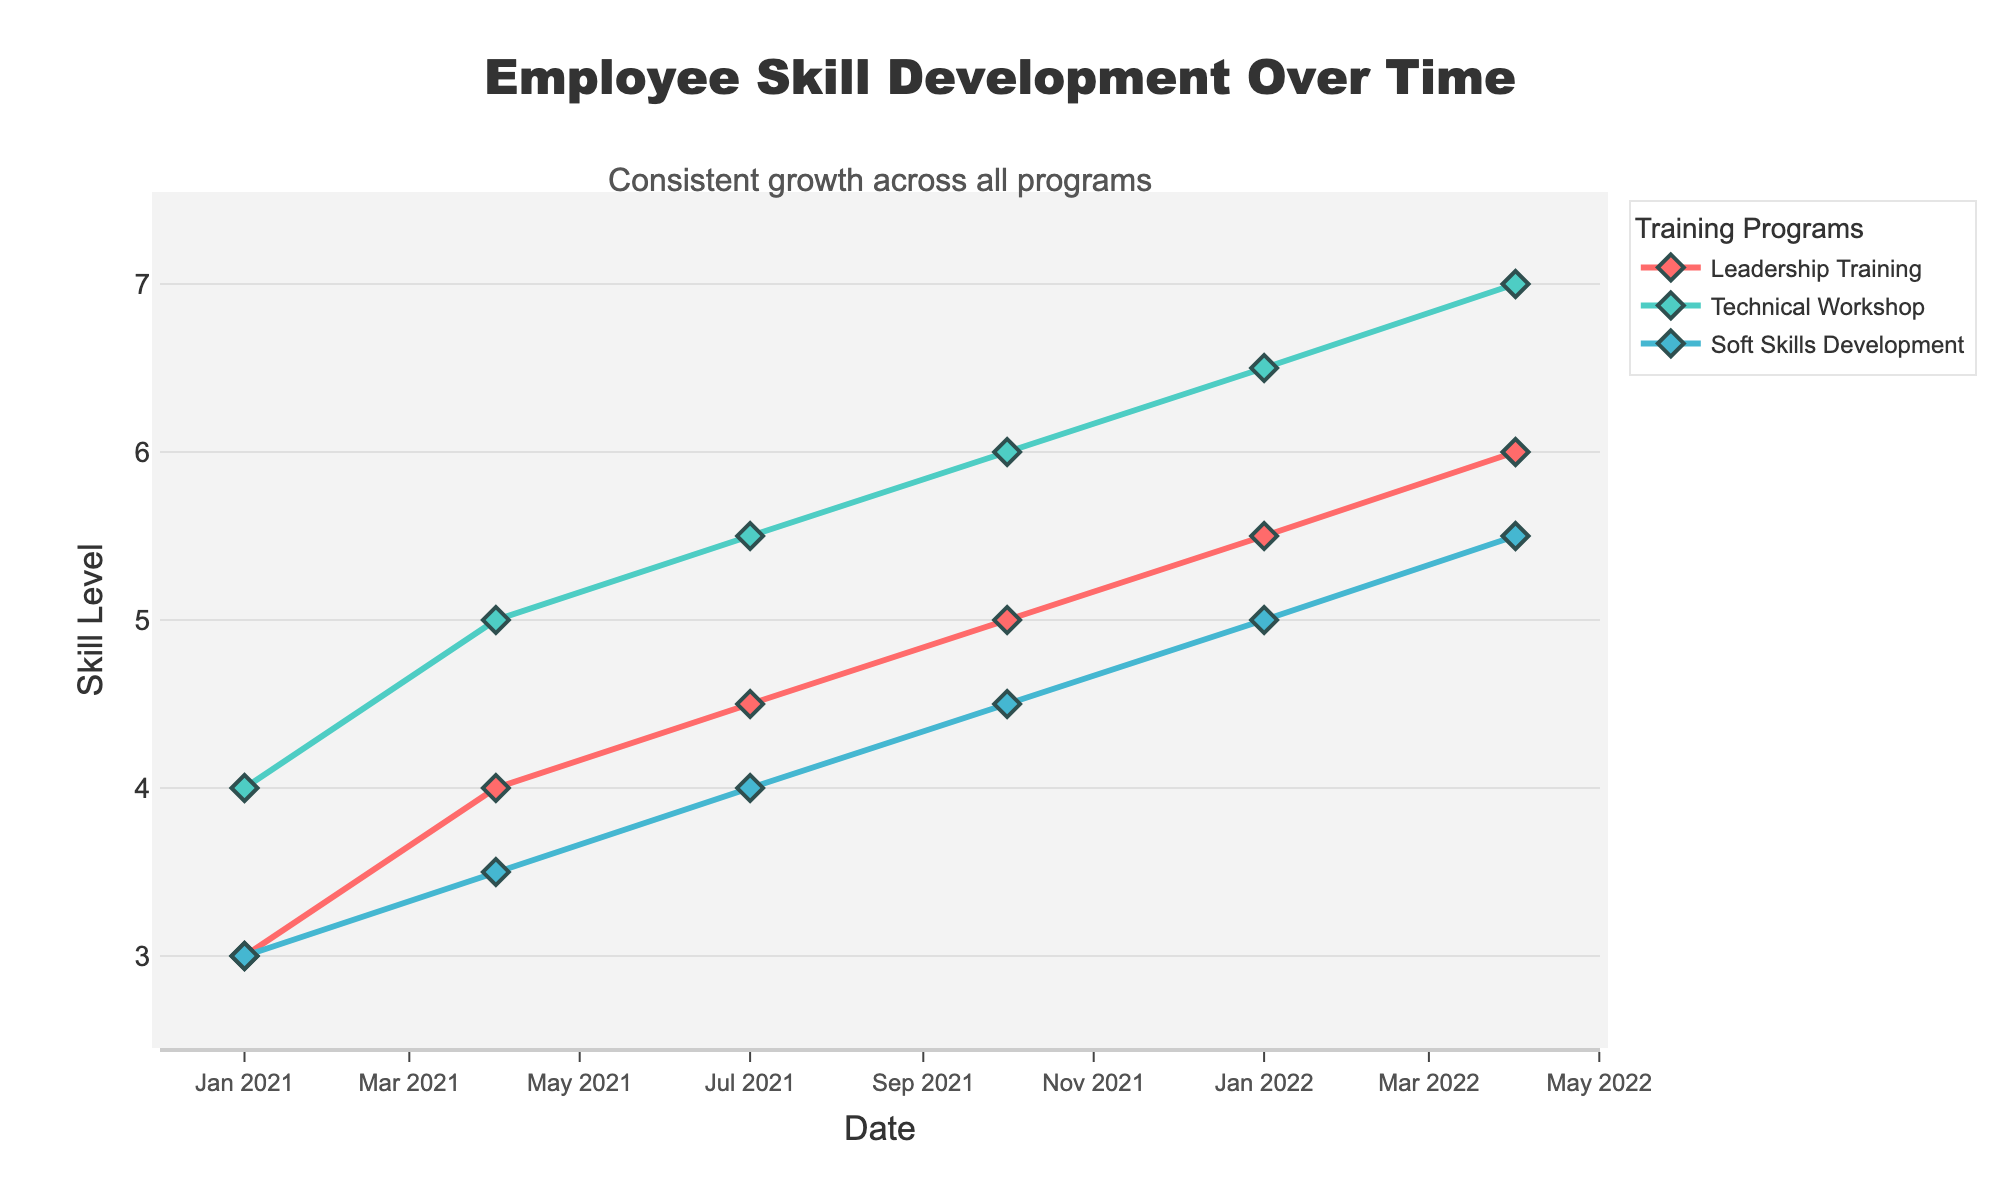What's the date range for the data displayed in the figure? The x-axis shows the first date is 2021-01-01 and the last date is 2022-04-01.
Answer: 2021-01-01 to 2022-04-01 Which training program showed the highest skill level at any point in time? At the end of the time series, we see "Technical Workshop" reaching a level of 7, higher than other programs.
Answer: Technical Workshop By how much did the skill level for the Soft Skills Development change from the first to the last date? The skill level for Soft Skills Development started at 3 on 2021-01-01 and increased to 5.5 by 2022-04-01, yielding a net change of 5.5 - 3 = 2.5.
Answer: 2.5 Which training program had the most consistent growth over time? The "Leadership Training" program saw smooth and continuous increases at every time point, indicating consistent growth.
Answer: Leadership Training Between which consecutive dates did the Technical Workshop program show the greatest improvement in skill level? Analyzing the increments, the highest increase occurred between 2021-10-01 to 2022-01-01, where the skill level increased from 6 to 6.5, a difference of 0.5.
Answer: 2021-10-01 to 2022-01-01 What's the average skill level of Leadership Training across all dates? Sum the skill levels for Leadership Training across all dates: (3 + 4 + 4.5 + 5 + 5.5 + 6) = 28, and divide by the number of dates (6): 28 / 6 = 4.67.
Answer: 4.67 How does the ending skill level of Soft Skills Development compare with the starting skill level of Leadership Training? By the end, Soft Skills Development is at 5.5, while Leadership Training started at 3, a higher ending skill level for Soft Skills Development.
Answer: Higher From the figure, in which quarter did Leadership Training first surpass a skill level of 5? The plot shows Leadership Training reaches 5 between Q3 and Q4 of 2021, precisely in 2021-10-01.
Answer: 2021 Q4 What's the combined average annual growth rate for all programs from start to end? Calculate the difference in skill levels and average over the number of programs. Leadership Training grew by 6-3=3, Technical Workshop by 7-4=3, and Soft Skills Development by 5.5-3=2.5, over approximately 1.25 years, or 1.25 annual periods. The combined average annual growth rate is (3 + 3 + 2.5) / (3*1.25) = 6.67 / 3.75 = 1.78.
Answer: 1.78 